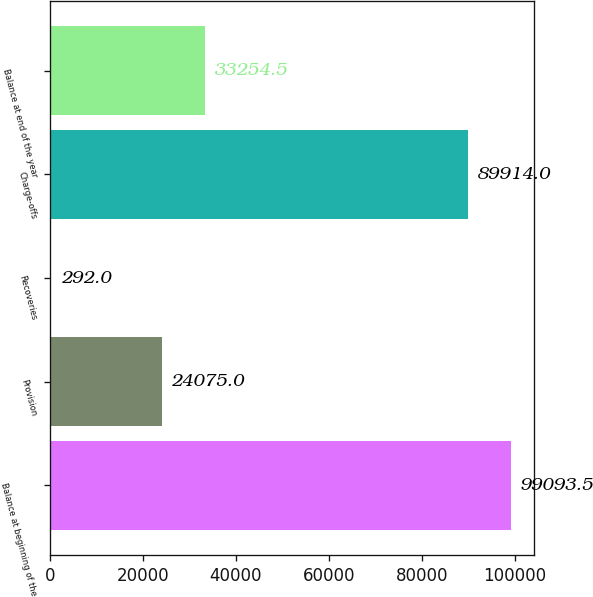Convert chart. <chart><loc_0><loc_0><loc_500><loc_500><bar_chart><fcel>Balance at beginning of the<fcel>Provision<fcel>Recoveries<fcel>Charge-offs<fcel>Balance at end of the year<nl><fcel>99093.5<fcel>24075<fcel>292<fcel>89914<fcel>33254.5<nl></chart> 